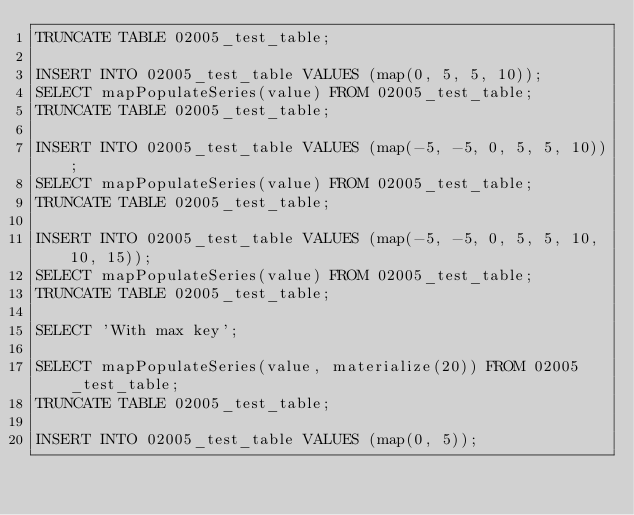Convert code to text. <code><loc_0><loc_0><loc_500><loc_500><_SQL_>TRUNCATE TABLE 02005_test_table;

INSERT INTO 02005_test_table VALUES (map(0, 5, 5, 10));
SELECT mapPopulateSeries(value) FROM 02005_test_table;
TRUNCATE TABLE 02005_test_table;

INSERT INTO 02005_test_table VALUES (map(-5, -5, 0, 5, 5, 10));
SELECT mapPopulateSeries(value) FROM 02005_test_table;
TRUNCATE TABLE 02005_test_table;

INSERT INTO 02005_test_table VALUES (map(-5, -5, 0, 5, 5, 10, 10, 15));
SELECT mapPopulateSeries(value) FROM 02005_test_table;
TRUNCATE TABLE 02005_test_table;

SELECT 'With max key';

SELECT mapPopulateSeries(value, materialize(20)) FROM 02005_test_table;
TRUNCATE TABLE 02005_test_table;

INSERT INTO 02005_test_table VALUES (map(0, 5));</code> 